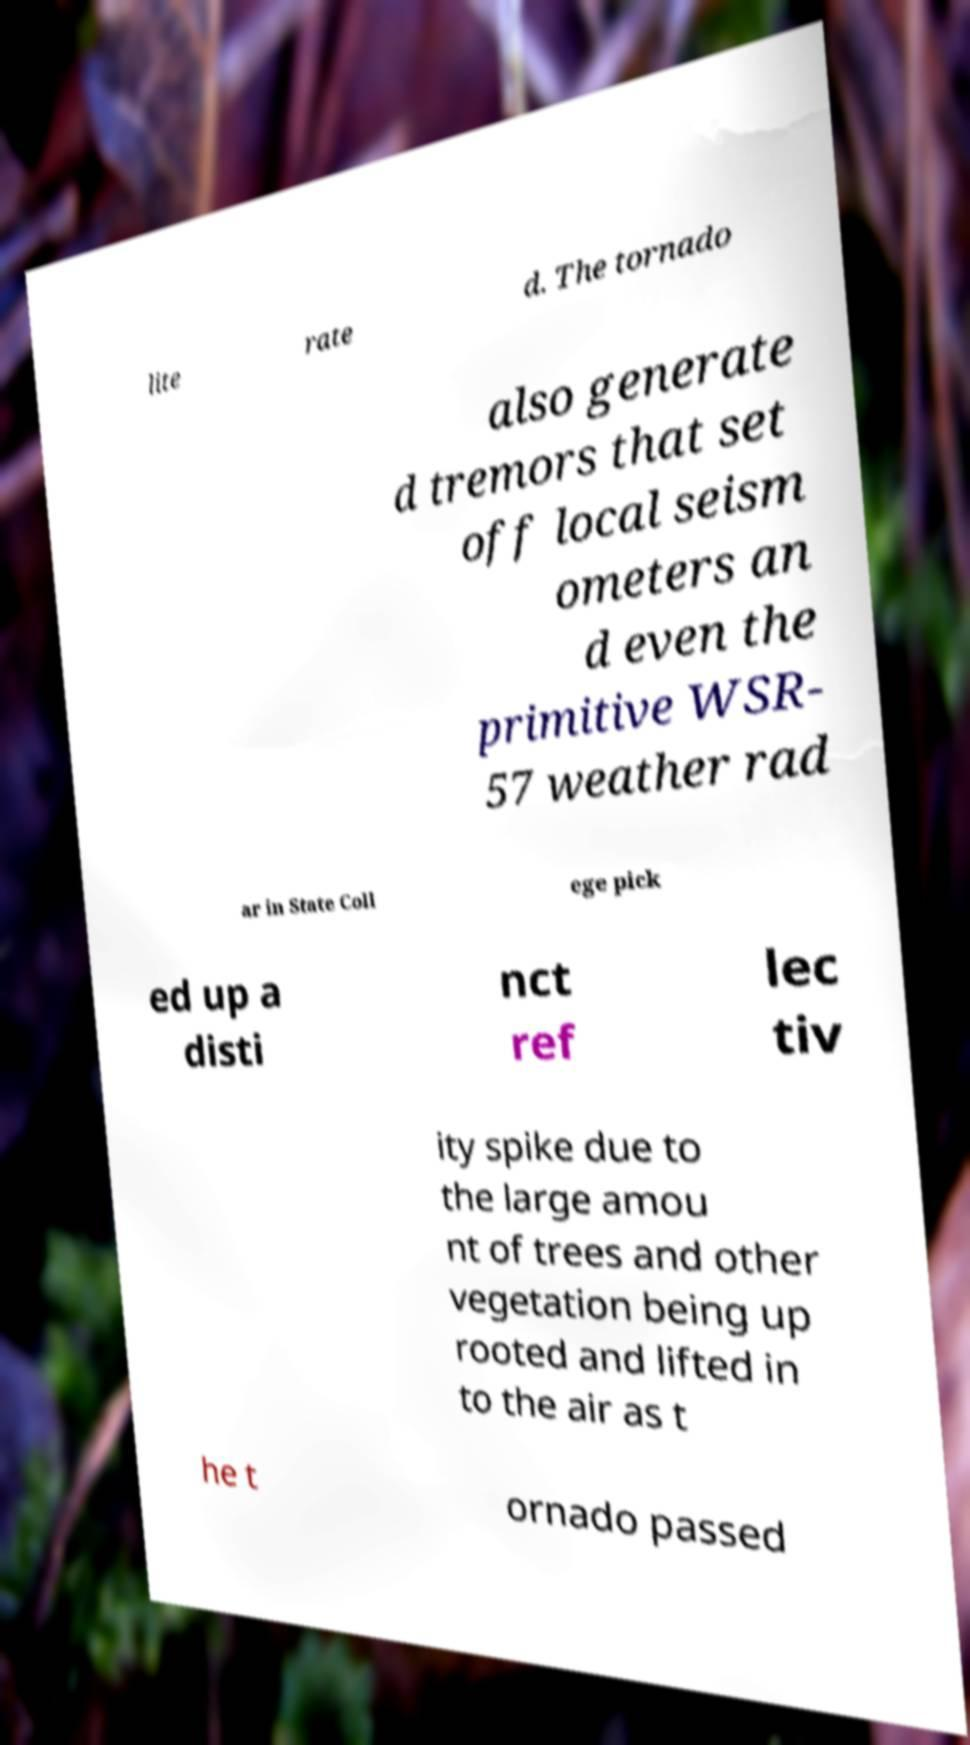Please read and relay the text visible in this image. What does it say? lite rate d. The tornado also generate d tremors that set off local seism ometers an d even the primitive WSR- 57 weather rad ar in State Coll ege pick ed up a disti nct ref lec tiv ity spike due to the large amou nt of trees and other vegetation being up rooted and lifted in to the air as t he t ornado passed 